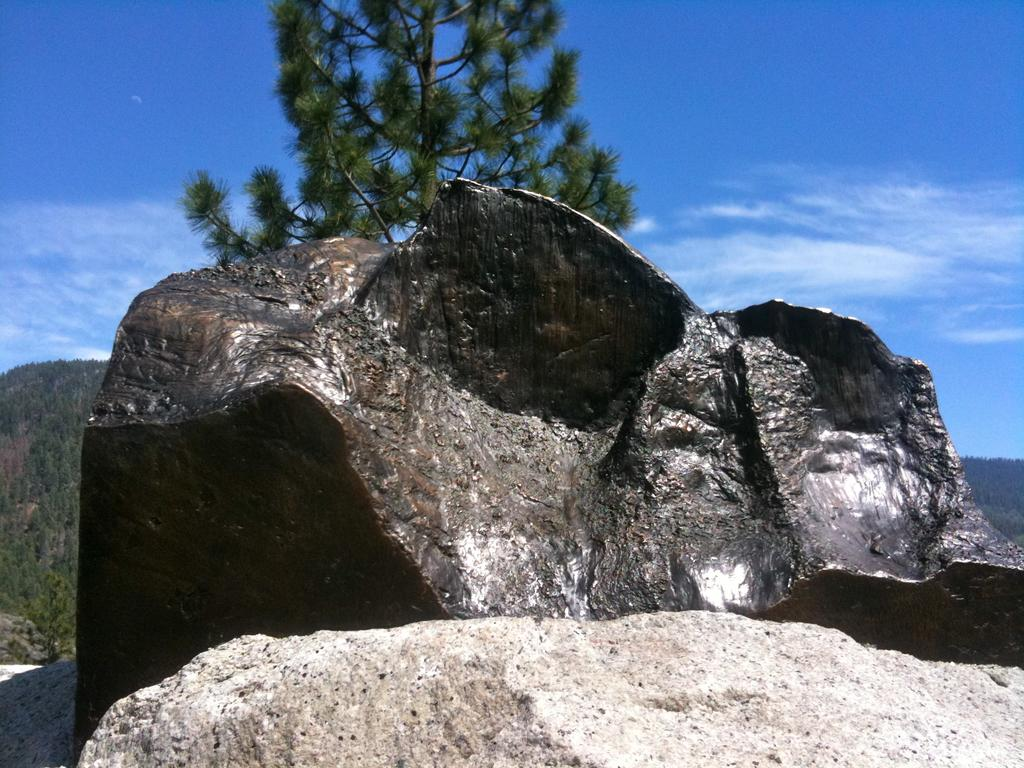What type of natural elements can be seen in the image? There are stones, a tree, and multiple trees visible in the image. Where is the tree located in the image? There is a tree in the front of the image. What can be seen in the background of the image? There are multiple trees and clouds visible in the background of the image. What part of the sky is visible in the image? The sky is visible in the background of the image. What type of list can be seen hanging from the tree in the image? There is no list present in the image; it features stones, trees, and clouds. How many nails are visible in the image? There are no nails visible in the image. 